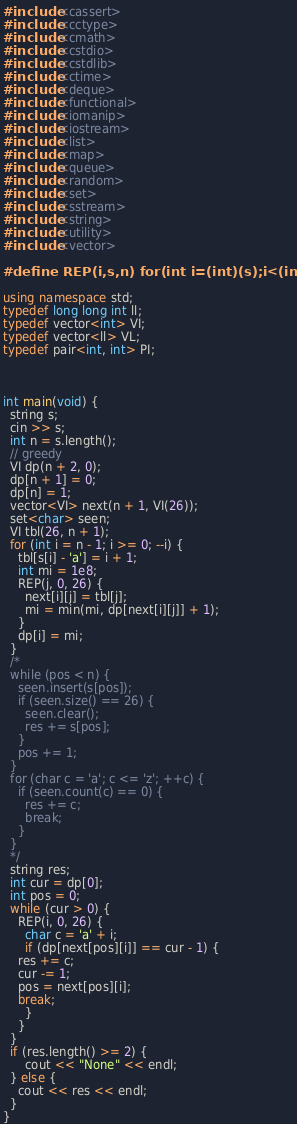Convert code to text. <code><loc_0><loc_0><loc_500><loc_500><_C++_>#include <cassert>
#include <cctype>
#include <cmath>
#include <cstdio>
#include <cstdlib>
#include <ctime>
#include <deque>
#include <functional>
#include <iomanip>
#include <iostream>
#include <list>
#include <map>
#include <queue>
#include <random>
#include <set>
#include <sstream>
#include <string>
#include <utility>
#include <vector>

#define REP(i,s,n) for(int i=(int)(s);i<(int)(n);i++)

using namespace std;
typedef long long int ll;
typedef vector<int> VI;
typedef vector<ll> VL;
typedef pair<int, int> PI;



int main(void) {
  string s;
  cin >> s;
  int n = s.length();
  // greedy
  VI dp(n + 2, 0);
  dp[n + 1] = 0;
  dp[n] = 1;
  vector<VI> next(n + 1, VI(26));
  set<char> seen;
  VI tbl(26, n + 1);
  for (int i = n - 1; i >= 0; --i) {
    tbl[s[i] - 'a'] = i + 1;
    int mi = 1e8;
    REP(j, 0, 26) {
      next[i][j] = tbl[j];
      mi = min(mi, dp[next[i][j]] + 1);
    }
    dp[i] = mi;
  }
  /*
  while (pos < n) {
    seen.insert(s[pos]);
    if (seen.size() == 26) {
      seen.clear();
      res += s[pos];
    }
    pos += 1;
  }
  for (char c = 'a'; c <= 'z'; ++c) {
    if (seen.count(c) == 0) {
      res += c;
      break;
    }
  }
  */
  string res;
  int cur = dp[0];
  int pos = 0;
  while (cur > 0) {
    REP(i, 0, 26) {
      char c = 'a' + i;
      if (dp[next[pos][i]] == cur - 1) {
	res += c;
	cur -= 1;
	pos = next[pos][i];
	break;
      }
    }
  }
  if (res.length() >= 2) {
	  cout << "None" << endl;
  } else {
    cout << res << endl;
  }
}
</code> 